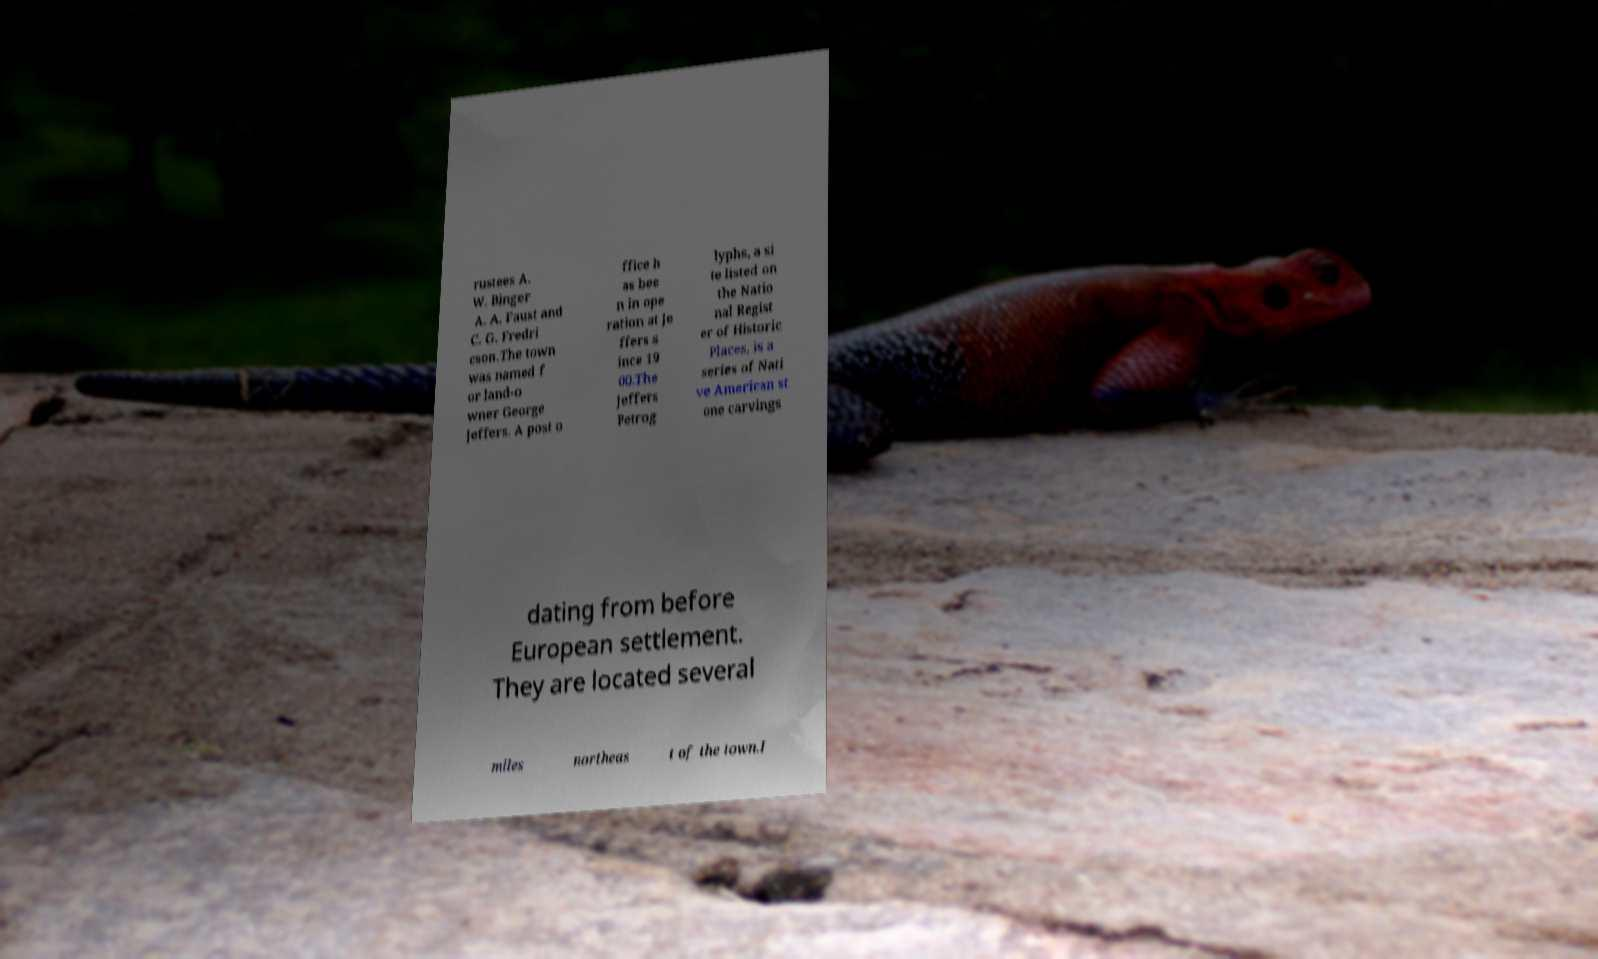For documentation purposes, I need the text within this image transcribed. Could you provide that? rustees A. W. Binger A. A. Faust and C. G. Fredri cson.The town was named f or land-o wner George Jeffers. A post o ffice h as bee n in ope ration at Je ffers s ince 19 00.The Jeffers Petrog lyphs, a si te listed on the Natio nal Regist er of Historic Places, is a series of Nati ve American st one carvings dating from before European settlement. They are located several miles northeas t of the town.I 